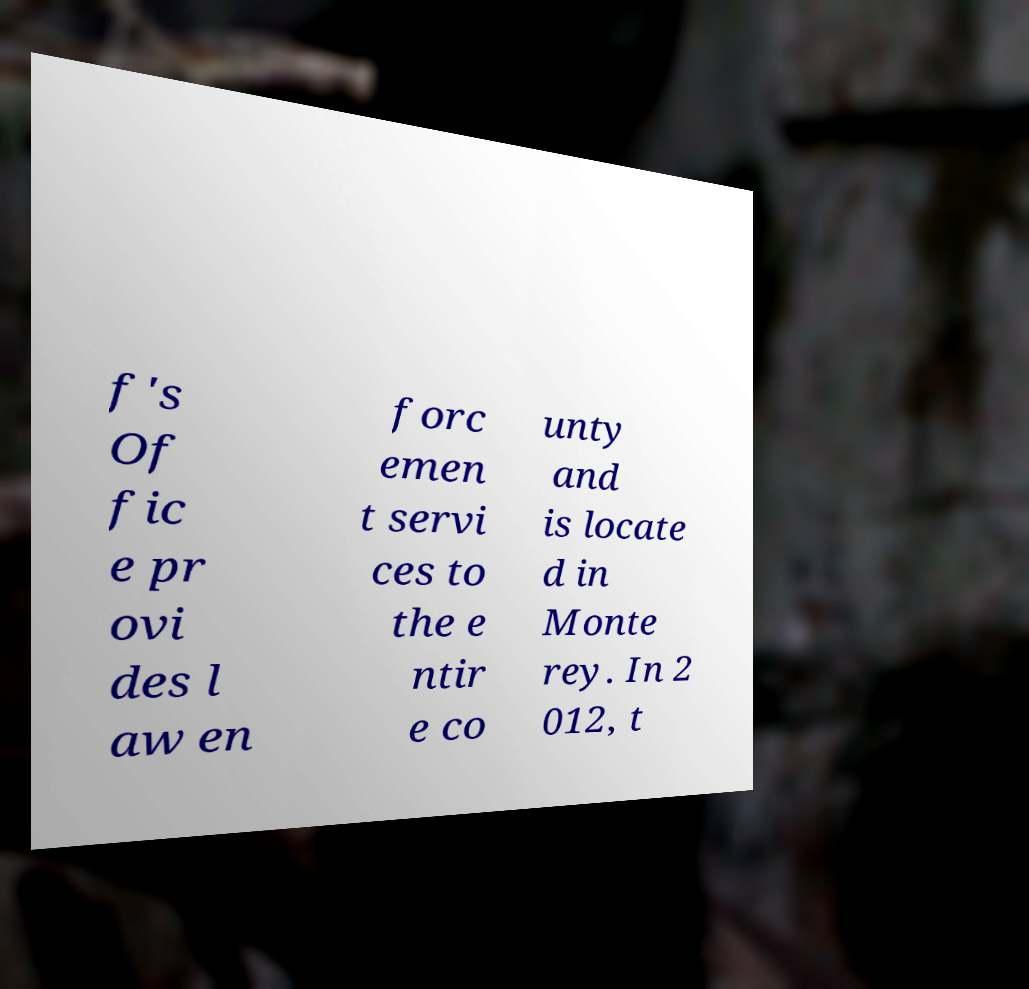Please read and relay the text visible in this image. What does it say? f's Of fic e pr ovi des l aw en forc emen t servi ces to the e ntir e co unty and is locate d in Monte rey. In 2 012, t 